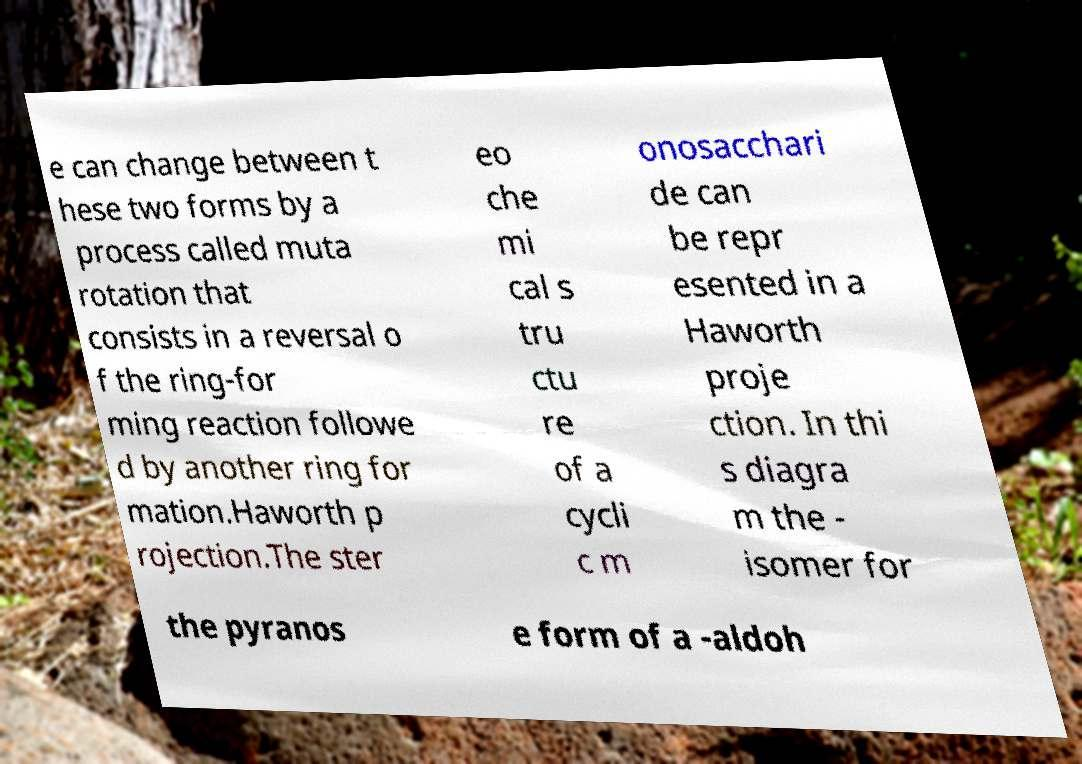For documentation purposes, I need the text within this image transcribed. Could you provide that? e can change between t hese two forms by a process called muta rotation that consists in a reversal o f the ring-for ming reaction followe d by another ring for mation.Haworth p rojection.The ster eo che mi cal s tru ctu re of a cycli c m onosacchari de can be repr esented in a Haworth proje ction. In thi s diagra m the - isomer for the pyranos e form of a -aldoh 